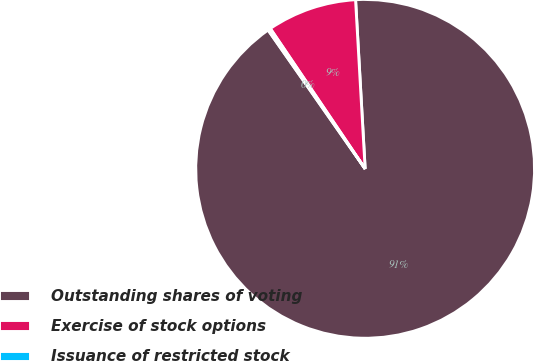<chart> <loc_0><loc_0><loc_500><loc_500><pie_chart><fcel>Outstanding shares of voting<fcel>Exercise of stock options<fcel>Issuance of restricted stock<nl><fcel>91.2%<fcel>8.56%<fcel>0.25%<nl></chart> 